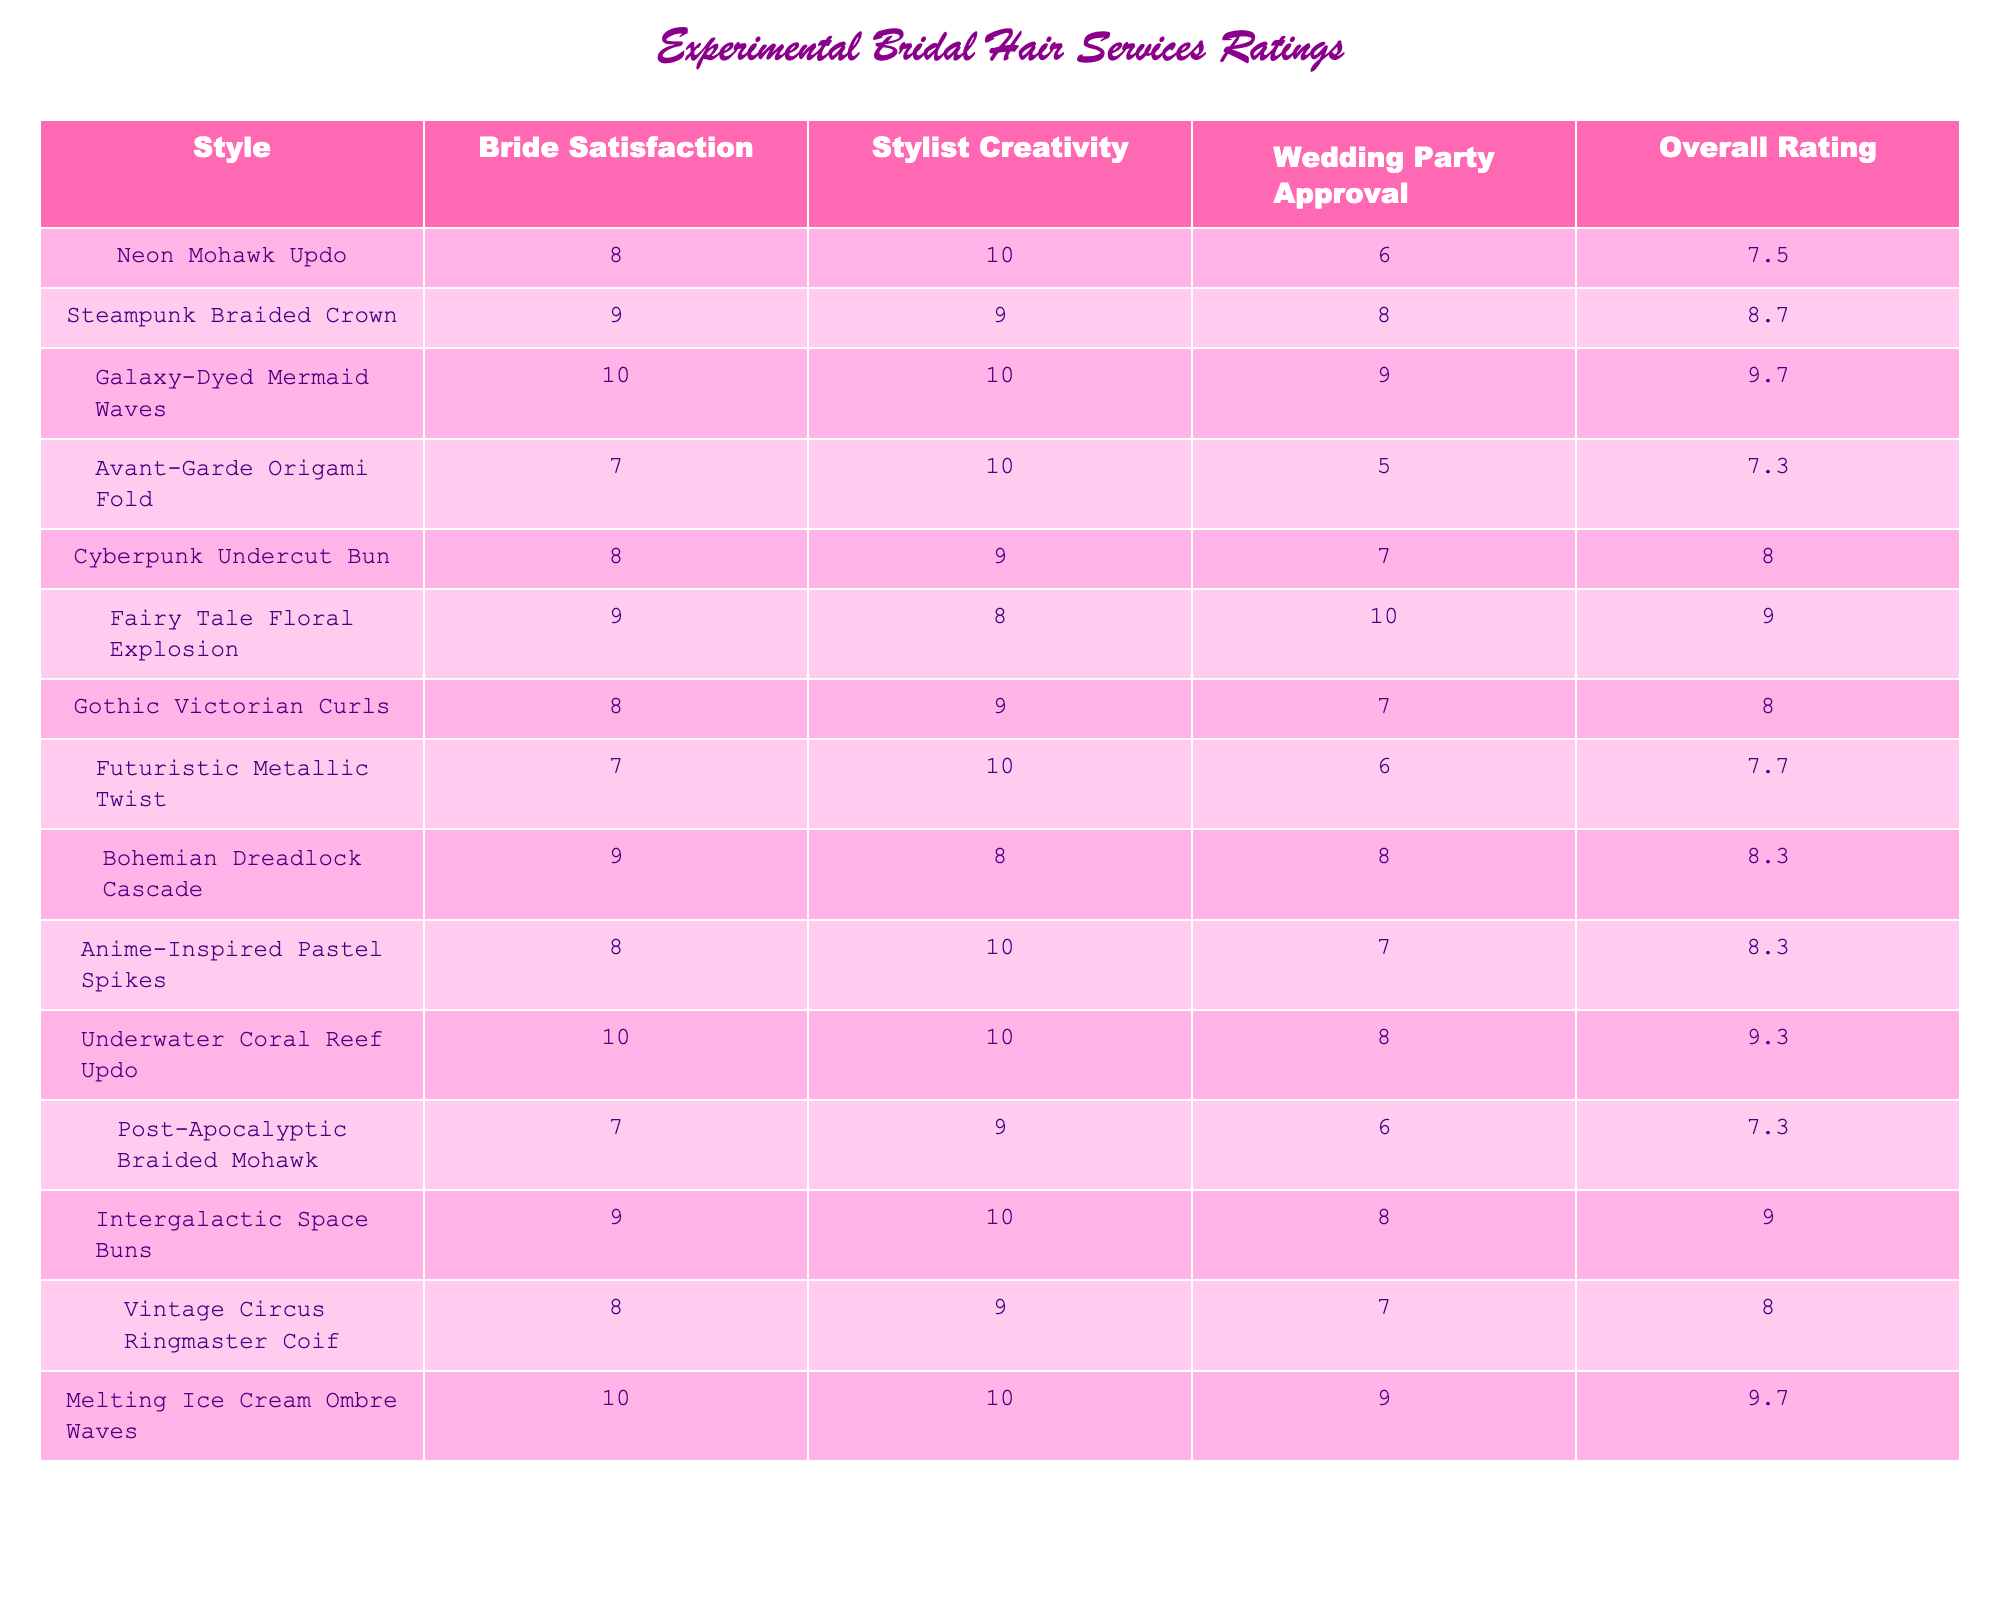What hairstyle received the highest score in Bride Satisfaction? The table lists the bride satisfaction scores for each hairstyle. The highest score is 10, which is achieved by both the Galaxy-Dyed Mermaid Waves and the Underwater Coral Reef Updo.
Answer: 10 Which hairstyle has the lowest Overall Rating? By looking at the Overall Rating column, the lowest score is 7.3, which is shared by both the Avant-Garde Origami Fold and the Post-Apocalyptic Braided Mohawk.
Answer: 7.3 What is the average Stylist Creativity score across all hairstyles? To find the average, we sum all the Stylist Creativity scores: (10 + 9 + 10 + 10 + 9 + 8 + 9 + 10 + 8 + 10 + 10 + 9 + 9 + 9 + 10) = 139. There are 15 hairstyles, so the average is 139/15 ≈ 9.27.
Answer: 9.27 Did all hairstyles have a wedding party approval score of 8 or higher? We need to check the Wedding Party Approval column. The lowest score is 5 for the Avant-Garde Origami Fold, indicating that not all hairstyles met the threshold of 8 or higher.
Answer: No Which hairstyle had the highest Overall Rating and was also approved by the wedding party? The table shows that the Galaxy-Dyed Mermaid Waves and Melting Ice Cream Ombre Waves both have an Overall Rating of 9.7. The Galaxy-Dyed Mermaid Waves received a Wedding Party Approval score of 9, and Melting Ice Cream Ombre Waves received a score of 9, meaning both meet this criterion.
Answer: Galaxy-Dyed Mermaid Waves and Melting Ice Cream Ombre Waves What is the difference between the highest and lowest scores in Stylist Creativity? The highest Stylist Creativity score is 10 and the lowest is 8. The difference is calculated as 10 - 8 = 2.
Answer: 2 Which hairstyle had the highest discrepancy between Bride Satisfaction and Wedding Party Approval? We compare the scores: Neon Mohawk Updo has a difference of 2 (8 - 6), Avant-Garde Origami Fold has a difference of 2 (7 - 5), and Cyberpunk Undercut Bun has a difference of 1 (8 - 7). The highest discrepancies are both from the Neon Mohawk Updo and Avant-Garde Origami Fold.
Answer: Neon Mohawk Updo and Avant-Garde Origami Fold What percentage of hairstyles scored an Overall Rating of 8 or above? There are 15 hairstyles in total. Counting those with a score of 8 or higher, we find 10 hairstyles. The percentage is then calculated as (10/15) * 100 = 66.67%.
Answer: 66.67% What correlation exists between Stylist Creativity and Overall Rating for hairstyles with a Bride Satisfaction score of 8 or higher? The relevant hairstyles that meet the criteria are the Neon Mohawk Updo, Steampunk Braided Crown, Galaxy-Dyed Mermaid Waves, Fairy Tale Floral Explosion, Bohemian Dreadlock Cascade, Anime-Inspired Pastel Spikes, Underwater Coral Reef Updo, Intergalactic Space Buns, and Melting Ice Cream Ombre Waves. Analyzing these shows a positive correlation between high creativity scores and higher Overall Ratings.
Answer: Positive correlation 